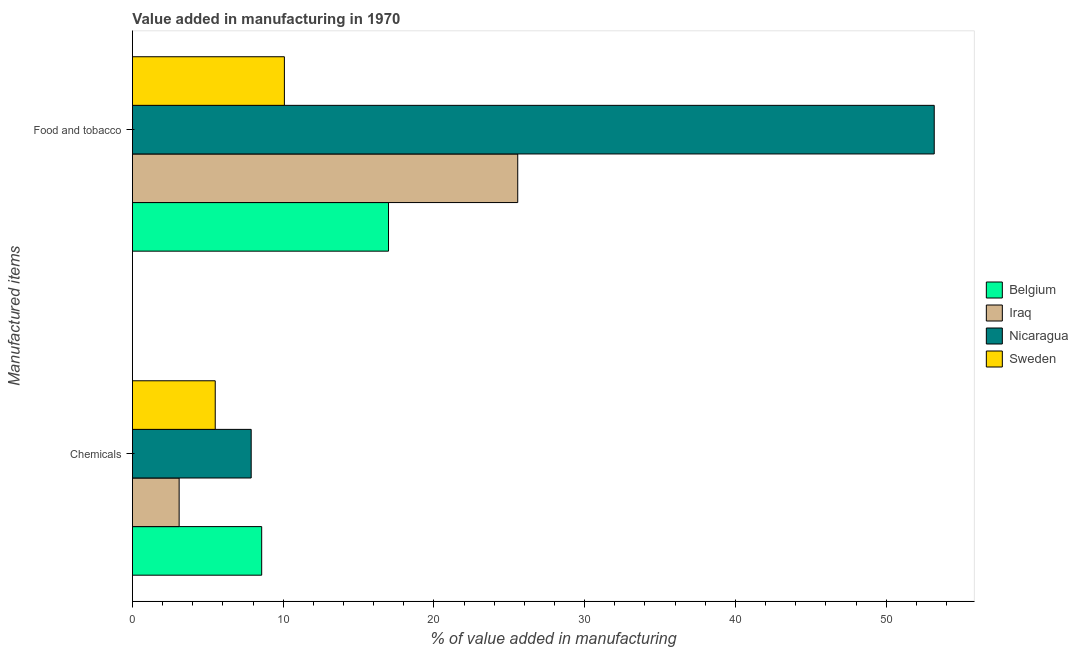How many groups of bars are there?
Offer a very short reply. 2. Are the number of bars on each tick of the Y-axis equal?
Provide a short and direct response. Yes. How many bars are there on the 1st tick from the top?
Provide a succinct answer. 4. How many bars are there on the 1st tick from the bottom?
Provide a short and direct response. 4. What is the label of the 1st group of bars from the top?
Ensure brevity in your answer.  Food and tobacco. What is the value added by  manufacturing chemicals in Sweden?
Your response must be concise. 5.49. Across all countries, what is the maximum value added by  manufacturing chemicals?
Your response must be concise. 8.57. Across all countries, what is the minimum value added by  manufacturing chemicals?
Your response must be concise. 3.1. In which country was the value added by manufacturing food and tobacco maximum?
Your response must be concise. Nicaragua. In which country was the value added by  manufacturing chemicals minimum?
Offer a terse response. Iraq. What is the total value added by manufacturing food and tobacco in the graph?
Provide a succinct answer. 105.81. What is the difference between the value added by manufacturing food and tobacco in Belgium and that in Nicaragua?
Offer a very short reply. -36.2. What is the difference between the value added by manufacturing food and tobacco in Belgium and the value added by  manufacturing chemicals in Sweden?
Provide a short and direct response. 11.49. What is the average value added by manufacturing food and tobacco per country?
Your response must be concise. 26.45. What is the difference between the value added by manufacturing food and tobacco and value added by  manufacturing chemicals in Sweden?
Provide a short and direct response. 4.59. What is the ratio of the value added by manufacturing food and tobacco in Belgium to that in Nicaragua?
Make the answer very short. 0.32. Is the value added by manufacturing food and tobacco in Iraq less than that in Belgium?
Keep it short and to the point. No. What does the 2nd bar from the bottom in Food and tobacco represents?
Keep it short and to the point. Iraq. How many countries are there in the graph?
Provide a succinct answer. 4. Are the values on the major ticks of X-axis written in scientific E-notation?
Make the answer very short. No. Does the graph contain any zero values?
Give a very brief answer. No. Does the graph contain grids?
Your answer should be very brief. No. How many legend labels are there?
Give a very brief answer. 4. What is the title of the graph?
Your answer should be very brief. Value added in manufacturing in 1970. What is the label or title of the X-axis?
Provide a succinct answer. % of value added in manufacturing. What is the label or title of the Y-axis?
Provide a succinct answer. Manufactured items. What is the % of value added in manufacturing in Belgium in Chemicals?
Your answer should be very brief. 8.57. What is the % of value added in manufacturing of Iraq in Chemicals?
Make the answer very short. 3.1. What is the % of value added in manufacturing of Nicaragua in Chemicals?
Offer a terse response. 7.88. What is the % of value added in manufacturing of Sweden in Chemicals?
Give a very brief answer. 5.49. What is the % of value added in manufacturing in Belgium in Food and tobacco?
Keep it short and to the point. 16.99. What is the % of value added in manufacturing of Iraq in Food and tobacco?
Offer a terse response. 25.56. What is the % of value added in manufacturing of Nicaragua in Food and tobacco?
Provide a short and direct response. 53.19. What is the % of value added in manufacturing in Sweden in Food and tobacco?
Provide a succinct answer. 10.08. Across all Manufactured items, what is the maximum % of value added in manufacturing in Belgium?
Provide a succinct answer. 16.99. Across all Manufactured items, what is the maximum % of value added in manufacturing of Iraq?
Offer a terse response. 25.56. Across all Manufactured items, what is the maximum % of value added in manufacturing of Nicaragua?
Offer a terse response. 53.19. Across all Manufactured items, what is the maximum % of value added in manufacturing of Sweden?
Your response must be concise. 10.08. Across all Manufactured items, what is the minimum % of value added in manufacturing in Belgium?
Keep it short and to the point. 8.57. Across all Manufactured items, what is the minimum % of value added in manufacturing in Iraq?
Make the answer very short. 3.1. Across all Manufactured items, what is the minimum % of value added in manufacturing of Nicaragua?
Your response must be concise. 7.88. Across all Manufactured items, what is the minimum % of value added in manufacturing of Sweden?
Ensure brevity in your answer.  5.49. What is the total % of value added in manufacturing in Belgium in the graph?
Your answer should be very brief. 25.56. What is the total % of value added in manufacturing of Iraq in the graph?
Give a very brief answer. 28.66. What is the total % of value added in manufacturing of Nicaragua in the graph?
Your answer should be very brief. 61.06. What is the total % of value added in manufacturing of Sweden in the graph?
Offer a very short reply. 15.57. What is the difference between the % of value added in manufacturing of Belgium in Chemicals and that in Food and tobacco?
Your answer should be compact. -8.41. What is the difference between the % of value added in manufacturing of Iraq in Chemicals and that in Food and tobacco?
Your answer should be compact. -22.46. What is the difference between the % of value added in manufacturing in Nicaragua in Chemicals and that in Food and tobacco?
Your response must be concise. -45.31. What is the difference between the % of value added in manufacturing in Sweden in Chemicals and that in Food and tobacco?
Make the answer very short. -4.59. What is the difference between the % of value added in manufacturing in Belgium in Chemicals and the % of value added in manufacturing in Iraq in Food and tobacco?
Offer a very short reply. -16.98. What is the difference between the % of value added in manufacturing of Belgium in Chemicals and the % of value added in manufacturing of Nicaragua in Food and tobacco?
Offer a terse response. -44.61. What is the difference between the % of value added in manufacturing of Belgium in Chemicals and the % of value added in manufacturing of Sweden in Food and tobacco?
Your answer should be compact. -1.51. What is the difference between the % of value added in manufacturing of Iraq in Chemicals and the % of value added in manufacturing of Nicaragua in Food and tobacco?
Offer a very short reply. -50.09. What is the difference between the % of value added in manufacturing in Iraq in Chemicals and the % of value added in manufacturing in Sweden in Food and tobacco?
Your response must be concise. -6.98. What is the difference between the % of value added in manufacturing in Nicaragua in Chemicals and the % of value added in manufacturing in Sweden in Food and tobacco?
Offer a very short reply. -2.2. What is the average % of value added in manufacturing of Belgium per Manufactured items?
Provide a short and direct response. 12.78. What is the average % of value added in manufacturing in Iraq per Manufactured items?
Provide a succinct answer. 14.33. What is the average % of value added in manufacturing in Nicaragua per Manufactured items?
Your answer should be very brief. 30.53. What is the average % of value added in manufacturing in Sweden per Manufactured items?
Your response must be concise. 7.79. What is the difference between the % of value added in manufacturing of Belgium and % of value added in manufacturing of Iraq in Chemicals?
Your answer should be very brief. 5.48. What is the difference between the % of value added in manufacturing of Belgium and % of value added in manufacturing of Nicaragua in Chemicals?
Your answer should be compact. 0.7. What is the difference between the % of value added in manufacturing of Belgium and % of value added in manufacturing of Sweden in Chemicals?
Give a very brief answer. 3.08. What is the difference between the % of value added in manufacturing of Iraq and % of value added in manufacturing of Nicaragua in Chemicals?
Your answer should be very brief. -4.78. What is the difference between the % of value added in manufacturing in Iraq and % of value added in manufacturing in Sweden in Chemicals?
Keep it short and to the point. -2.39. What is the difference between the % of value added in manufacturing in Nicaragua and % of value added in manufacturing in Sweden in Chemicals?
Keep it short and to the point. 2.38. What is the difference between the % of value added in manufacturing in Belgium and % of value added in manufacturing in Iraq in Food and tobacco?
Ensure brevity in your answer.  -8.57. What is the difference between the % of value added in manufacturing of Belgium and % of value added in manufacturing of Nicaragua in Food and tobacco?
Make the answer very short. -36.2. What is the difference between the % of value added in manufacturing of Belgium and % of value added in manufacturing of Sweden in Food and tobacco?
Keep it short and to the point. 6.91. What is the difference between the % of value added in manufacturing of Iraq and % of value added in manufacturing of Nicaragua in Food and tobacco?
Provide a short and direct response. -27.63. What is the difference between the % of value added in manufacturing in Iraq and % of value added in manufacturing in Sweden in Food and tobacco?
Ensure brevity in your answer.  15.48. What is the difference between the % of value added in manufacturing of Nicaragua and % of value added in manufacturing of Sweden in Food and tobacco?
Your response must be concise. 43.11. What is the ratio of the % of value added in manufacturing in Belgium in Chemicals to that in Food and tobacco?
Your answer should be compact. 0.5. What is the ratio of the % of value added in manufacturing in Iraq in Chemicals to that in Food and tobacco?
Your answer should be very brief. 0.12. What is the ratio of the % of value added in manufacturing of Nicaragua in Chemicals to that in Food and tobacco?
Your response must be concise. 0.15. What is the ratio of the % of value added in manufacturing of Sweden in Chemicals to that in Food and tobacco?
Provide a short and direct response. 0.54. What is the difference between the highest and the second highest % of value added in manufacturing of Belgium?
Your answer should be very brief. 8.41. What is the difference between the highest and the second highest % of value added in manufacturing of Iraq?
Ensure brevity in your answer.  22.46. What is the difference between the highest and the second highest % of value added in manufacturing in Nicaragua?
Your response must be concise. 45.31. What is the difference between the highest and the second highest % of value added in manufacturing in Sweden?
Your response must be concise. 4.59. What is the difference between the highest and the lowest % of value added in manufacturing of Belgium?
Offer a terse response. 8.41. What is the difference between the highest and the lowest % of value added in manufacturing of Iraq?
Make the answer very short. 22.46. What is the difference between the highest and the lowest % of value added in manufacturing of Nicaragua?
Ensure brevity in your answer.  45.31. What is the difference between the highest and the lowest % of value added in manufacturing of Sweden?
Provide a short and direct response. 4.59. 